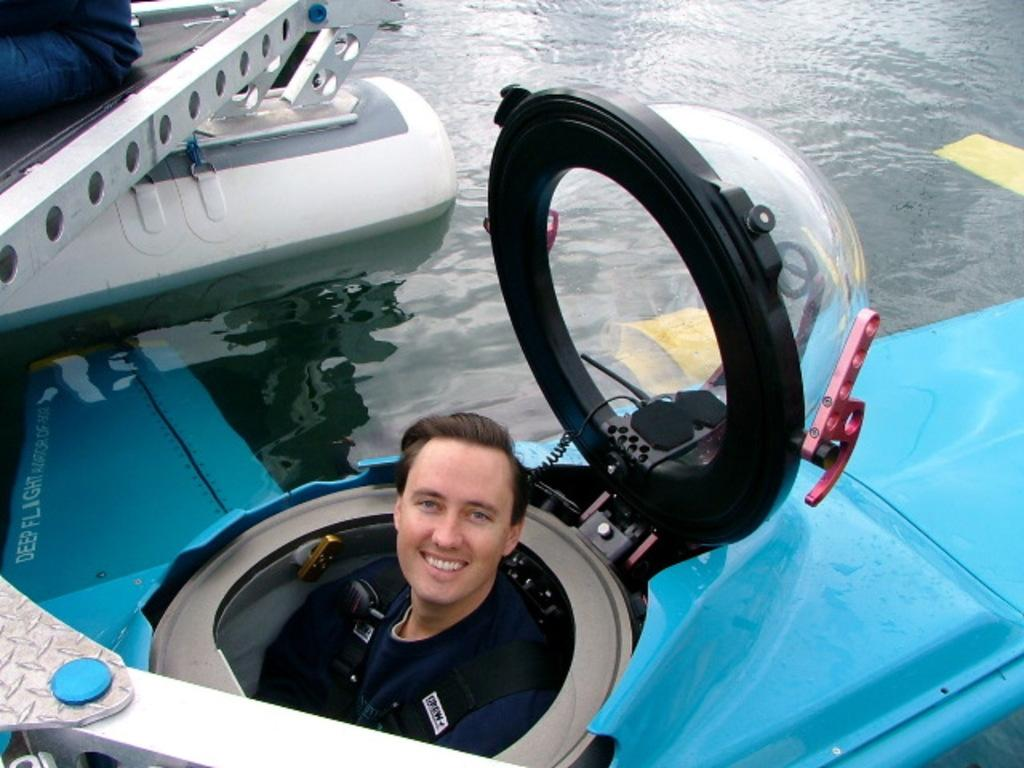What is the man inside the vehicle doing in the image? The man is inside a vehicle that is on the water. Can you describe the location of the vehicle in the image? The vehicle is on the water. How many people are visible in the image? There is one person visible in the image. What type of chicken can be seen swimming in the water near the vehicle? There is no chicken present in the image, and therefore no such activity can be observed. How does the wren contribute to the design of the vehicle in the image? There is no wren present in the image, and therefore it cannot contribute to the design of the vehicle. 